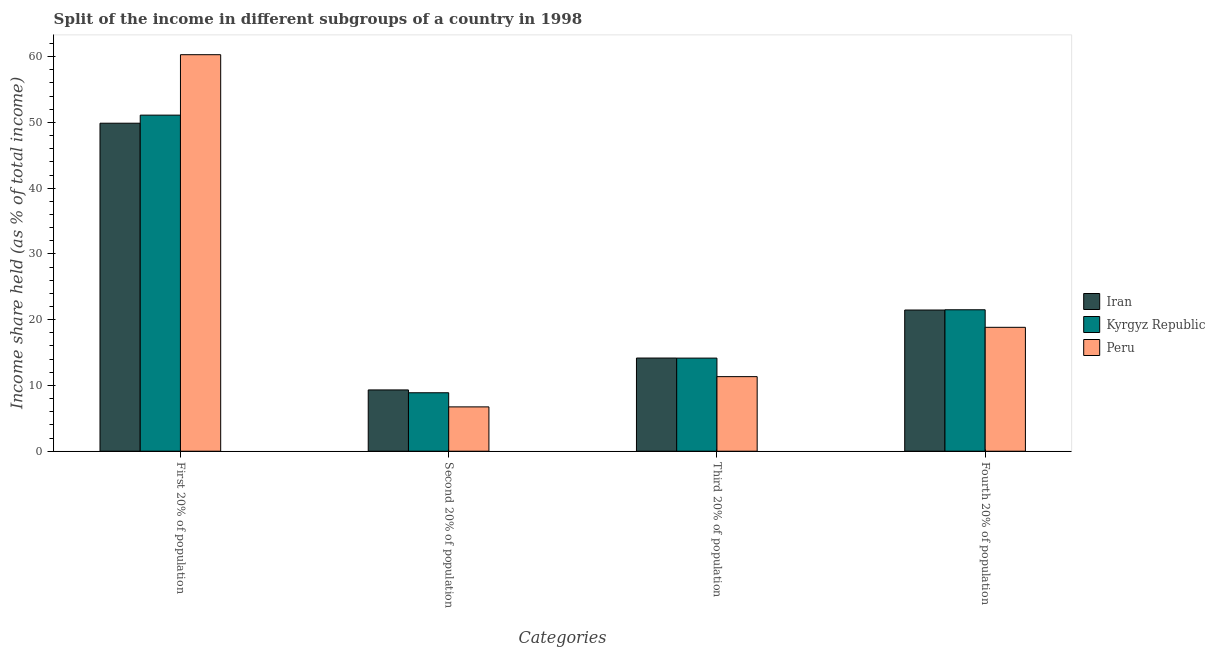How many different coloured bars are there?
Offer a terse response. 3. What is the label of the 1st group of bars from the left?
Make the answer very short. First 20% of population. What is the share of the income held by first 20% of the population in Kyrgyz Republic?
Your response must be concise. 51.11. Across all countries, what is the maximum share of the income held by fourth 20% of the population?
Keep it short and to the point. 21.51. Across all countries, what is the minimum share of the income held by second 20% of the population?
Make the answer very short. 6.74. In which country was the share of the income held by first 20% of the population maximum?
Give a very brief answer. Peru. What is the total share of the income held by third 20% of the population in the graph?
Provide a short and direct response. 39.67. What is the difference between the share of the income held by third 20% of the population in Iran and that in Kyrgyz Republic?
Your response must be concise. 0.01. What is the difference between the share of the income held by second 20% of the population in Kyrgyz Republic and the share of the income held by first 20% of the population in Iran?
Offer a terse response. -40.99. What is the average share of the income held by first 20% of the population per country?
Give a very brief answer. 53.76. What is the difference between the share of the income held by fourth 20% of the population and share of the income held by first 20% of the population in Kyrgyz Republic?
Make the answer very short. -29.6. What is the ratio of the share of the income held by fourth 20% of the population in Peru to that in Iran?
Provide a succinct answer. 0.88. Is the difference between the share of the income held by second 20% of the population in Kyrgyz Republic and Peru greater than the difference between the share of the income held by third 20% of the population in Kyrgyz Republic and Peru?
Your response must be concise. No. What is the difference between the highest and the second highest share of the income held by second 20% of the population?
Your answer should be very brief. 0.43. What is the difference between the highest and the lowest share of the income held by second 20% of the population?
Your response must be concise. 2.58. In how many countries, is the share of the income held by fourth 20% of the population greater than the average share of the income held by fourth 20% of the population taken over all countries?
Provide a succinct answer. 2. Is the sum of the share of the income held by second 20% of the population in Kyrgyz Republic and Peru greater than the maximum share of the income held by fourth 20% of the population across all countries?
Provide a succinct answer. No. Is it the case that in every country, the sum of the share of the income held by second 20% of the population and share of the income held by fourth 20% of the population is greater than the sum of share of the income held by third 20% of the population and share of the income held by first 20% of the population?
Your answer should be very brief. Yes. What does the 1st bar from the left in Second 20% of population represents?
Keep it short and to the point. Iran. How many bars are there?
Make the answer very short. 12. How many countries are there in the graph?
Ensure brevity in your answer.  3. What is the difference between two consecutive major ticks on the Y-axis?
Keep it short and to the point. 10. Are the values on the major ticks of Y-axis written in scientific E-notation?
Your answer should be very brief. No. Does the graph contain any zero values?
Keep it short and to the point. No. Does the graph contain grids?
Provide a short and direct response. No. What is the title of the graph?
Give a very brief answer. Split of the income in different subgroups of a country in 1998. Does "Slovak Republic" appear as one of the legend labels in the graph?
Make the answer very short. No. What is the label or title of the X-axis?
Offer a very short reply. Categories. What is the label or title of the Y-axis?
Make the answer very short. Income share held (as % of total income). What is the Income share held (as % of total income) in Iran in First 20% of population?
Provide a succinct answer. 49.88. What is the Income share held (as % of total income) of Kyrgyz Republic in First 20% of population?
Offer a very short reply. 51.11. What is the Income share held (as % of total income) in Peru in First 20% of population?
Provide a succinct answer. 60.3. What is the Income share held (as % of total income) of Iran in Second 20% of population?
Your response must be concise. 9.32. What is the Income share held (as % of total income) in Kyrgyz Republic in Second 20% of population?
Provide a short and direct response. 8.89. What is the Income share held (as % of total income) in Peru in Second 20% of population?
Make the answer very short. 6.74. What is the Income share held (as % of total income) in Iran in Third 20% of population?
Make the answer very short. 14.17. What is the Income share held (as % of total income) in Kyrgyz Republic in Third 20% of population?
Your answer should be compact. 14.16. What is the Income share held (as % of total income) in Peru in Third 20% of population?
Keep it short and to the point. 11.34. What is the Income share held (as % of total income) of Iran in Fourth 20% of population?
Keep it short and to the point. 21.47. What is the Income share held (as % of total income) in Kyrgyz Republic in Fourth 20% of population?
Offer a terse response. 21.51. What is the Income share held (as % of total income) of Peru in Fourth 20% of population?
Your answer should be compact. 18.84. Across all Categories, what is the maximum Income share held (as % of total income) of Iran?
Give a very brief answer. 49.88. Across all Categories, what is the maximum Income share held (as % of total income) in Kyrgyz Republic?
Your answer should be very brief. 51.11. Across all Categories, what is the maximum Income share held (as % of total income) in Peru?
Make the answer very short. 60.3. Across all Categories, what is the minimum Income share held (as % of total income) in Iran?
Offer a terse response. 9.32. Across all Categories, what is the minimum Income share held (as % of total income) in Kyrgyz Republic?
Your answer should be compact. 8.89. Across all Categories, what is the minimum Income share held (as % of total income) in Peru?
Your answer should be compact. 6.74. What is the total Income share held (as % of total income) of Iran in the graph?
Your answer should be very brief. 94.84. What is the total Income share held (as % of total income) in Kyrgyz Republic in the graph?
Your answer should be very brief. 95.67. What is the total Income share held (as % of total income) of Peru in the graph?
Your response must be concise. 97.22. What is the difference between the Income share held (as % of total income) in Iran in First 20% of population and that in Second 20% of population?
Keep it short and to the point. 40.56. What is the difference between the Income share held (as % of total income) in Kyrgyz Republic in First 20% of population and that in Second 20% of population?
Your answer should be very brief. 42.22. What is the difference between the Income share held (as % of total income) in Peru in First 20% of population and that in Second 20% of population?
Provide a succinct answer. 53.56. What is the difference between the Income share held (as % of total income) of Iran in First 20% of population and that in Third 20% of population?
Make the answer very short. 35.71. What is the difference between the Income share held (as % of total income) of Kyrgyz Republic in First 20% of population and that in Third 20% of population?
Offer a terse response. 36.95. What is the difference between the Income share held (as % of total income) in Peru in First 20% of population and that in Third 20% of population?
Keep it short and to the point. 48.96. What is the difference between the Income share held (as % of total income) of Iran in First 20% of population and that in Fourth 20% of population?
Offer a very short reply. 28.41. What is the difference between the Income share held (as % of total income) of Kyrgyz Republic in First 20% of population and that in Fourth 20% of population?
Ensure brevity in your answer.  29.6. What is the difference between the Income share held (as % of total income) in Peru in First 20% of population and that in Fourth 20% of population?
Offer a terse response. 41.46. What is the difference between the Income share held (as % of total income) in Iran in Second 20% of population and that in Third 20% of population?
Your answer should be very brief. -4.85. What is the difference between the Income share held (as % of total income) of Kyrgyz Republic in Second 20% of population and that in Third 20% of population?
Your answer should be compact. -5.27. What is the difference between the Income share held (as % of total income) in Peru in Second 20% of population and that in Third 20% of population?
Provide a succinct answer. -4.6. What is the difference between the Income share held (as % of total income) in Iran in Second 20% of population and that in Fourth 20% of population?
Your answer should be very brief. -12.15. What is the difference between the Income share held (as % of total income) of Kyrgyz Republic in Second 20% of population and that in Fourth 20% of population?
Your answer should be compact. -12.62. What is the difference between the Income share held (as % of total income) in Peru in Second 20% of population and that in Fourth 20% of population?
Offer a very short reply. -12.1. What is the difference between the Income share held (as % of total income) in Kyrgyz Republic in Third 20% of population and that in Fourth 20% of population?
Give a very brief answer. -7.35. What is the difference between the Income share held (as % of total income) in Iran in First 20% of population and the Income share held (as % of total income) in Kyrgyz Republic in Second 20% of population?
Your answer should be compact. 40.99. What is the difference between the Income share held (as % of total income) in Iran in First 20% of population and the Income share held (as % of total income) in Peru in Second 20% of population?
Provide a succinct answer. 43.14. What is the difference between the Income share held (as % of total income) in Kyrgyz Republic in First 20% of population and the Income share held (as % of total income) in Peru in Second 20% of population?
Provide a short and direct response. 44.37. What is the difference between the Income share held (as % of total income) in Iran in First 20% of population and the Income share held (as % of total income) in Kyrgyz Republic in Third 20% of population?
Offer a very short reply. 35.72. What is the difference between the Income share held (as % of total income) of Iran in First 20% of population and the Income share held (as % of total income) of Peru in Third 20% of population?
Your response must be concise. 38.54. What is the difference between the Income share held (as % of total income) of Kyrgyz Republic in First 20% of population and the Income share held (as % of total income) of Peru in Third 20% of population?
Provide a short and direct response. 39.77. What is the difference between the Income share held (as % of total income) of Iran in First 20% of population and the Income share held (as % of total income) of Kyrgyz Republic in Fourth 20% of population?
Make the answer very short. 28.37. What is the difference between the Income share held (as % of total income) of Iran in First 20% of population and the Income share held (as % of total income) of Peru in Fourth 20% of population?
Give a very brief answer. 31.04. What is the difference between the Income share held (as % of total income) in Kyrgyz Republic in First 20% of population and the Income share held (as % of total income) in Peru in Fourth 20% of population?
Ensure brevity in your answer.  32.27. What is the difference between the Income share held (as % of total income) of Iran in Second 20% of population and the Income share held (as % of total income) of Kyrgyz Republic in Third 20% of population?
Provide a short and direct response. -4.84. What is the difference between the Income share held (as % of total income) of Iran in Second 20% of population and the Income share held (as % of total income) of Peru in Third 20% of population?
Keep it short and to the point. -2.02. What is the difference between the Income share held (as % of total income) of Kyrgyz Republic in Second 20% of population and the Income share held (as % of total income) of Peru in Third 20% of population?
Provide a succinct answer. -2.45. What is the difference between the Income share held (as % of total income) in Iran in Second 20% of population and the Income share held (as % of total income) in Kyrgyz Republic in Fourth 20% of population?
Keep it short and to the point. -12.19. What is the difference between the Income share held (as % of total income) in Iran in Second 20% of population and the Income share held (as % of total income) in Peru in Fourth 20% of population?
Your answer should be compact. -9.52. What is the difference between the Income share held (as % of total income) in Kyrgyz Republic in Second 20% of population and the Income share held (as % of total income) in Peru in Fourth 20% of population?
Your answer should be compact. -9.95. What is the difference between the Income share held (as % of total income) of Iran in Third 20% of population and the Income share held (as % of total income) of Kyrgyz Republic in Fourth 20% of population?
Your response must be concise. -7.34. What is the difference between the Income share held (as % of total income) in Iran in Third 20% of population and the Income share held (as % of total income) in Peru in Fourth 20% of population?
Provide a short and direct response. -4.67. What is the difference between the Income share held (as % of total income) in Kyrgyz Republic in Third 20% of population and the Income share held (as % of total income) in Peru in Fourth 20% of population?
Offer a very short reply. -4.68. What is the average Income share held (as % of total income) in Iran per Categories?
Ensure brevity in your answer.  23.71. What is the average Income share held (as % of total income) in Kyrgyz Republic per Categories?
Ensure brevity in your answer.  23.92. What is the average Income share held (as % of total income) in Peru per Categories?
Provide a succinct answer. 24.3. What is the difference between the Income share held (as % of total income) of Iran and Income share held (as % of total income) of Kyrgyz Republic in First 20% of population?
Your response must be concise. -1.23. What is the difference between the Income share held (as % of total income) in Iran and Income share held (as % of total income) in Peru in First 20% of population?
Provide a succinct answer. -10.42. What is the difference between the Income share held (as % of total income) of Kyrgyz Republic and Income share held (as % of total income) of Peru in First 20% of population?
Give a very brief answer. -9.19. What is the difference between the Income share held (as % of total income) in Iran and Income share held (as % of total income) in Kyrgyz Republic in Second 20% of population?
Your answer should be compact. 0.43. What is the difference between the Income share held (as % of total income) of Iran and Income share held (as % of total income) of Peru in Second 20% of population?
Offer a terse response. 2.58. What is the difference between the Income share held (as % of total income) in Kyrgyz Republic and Income share held (as % of total income) in Peru in Second 20% of population?
Provide a succinct answer. 2.15. What is the difference between the Income share held (as % of total income) of Iran and Income share held (as % of total income) of Kyrgyz Republic in Third 20% of population?
Offer a very short reply. 0.01. What is the difference between the Income share held (as % of total income) in Iran and Income share held (as % of total income) in Peru in Third 20% of population?
Make the answer very short. 2.83. What is the difference between the Income share held (as % of total income) of Kyrgyz Republic and Income share held (as % of total income) of Peru in Third 20% of population?
Keep it short and to the point. 2.82. What is the difference between the Income share held (as % of total income) of Iran and Income share held (as % of total income) of Kyrgyz Republic in Fourth 20% of population?
Your answer should be very brief. -0.04. What is the difference between the Income share held (as % of total income) of Iran and Income share held (as % of total income) of Peru in Fourth 20% of population?
Provide a short and direct response. 2.63. What is the difference between the Income share held (as % of total income) in Kyrgyz Republic and Income share held (as % of total income) in Peru in Fourth 20% of population?
Your answer should be very brief. 2.67. What is the ratio of the Income share held (as % of total income) in Iran in First 20% of population to that in Second 20% of population?
Offer a very short reply. 5.35. What is the ratio of the Income share held (as % of total income) in Kyrgyz Republic in First 20% of population to that in Second 20% of population?
Provide a succinct answer. 5.75. What is the ratio of the Income share held (as % of total income) in Peru in First 20% of population to that in Second 20% of population?
Give a very brief answer. 8.95. What is the ratio of the Income share held (as % of total income) of Iran in First 20% of population to that in Third 20% of population?
Your response must be concise. 3.52. What is the ratio of the Income share held (as % of total income) in Kyrgyz Republic in First 20% of population to that in Third 20% of population?
Your answer should be very brief. 3.61. What is the ratio of the Income share held (as % of total income) in Peru in First 20% of population to that in Third 20% of population?
Provide a succinct answer. 5.32. What is the ratio of the Income share held (as % of total income) in Iran in First 20% of population to that in Fourth 20% of population?
Provide a short and direct response. 2.32. What is the ratio of the Income share held (as % of total income) in Kyrgyz Republic in First 20% of population to that in Fourth 20% of population?
Provide a succinct answer. 2.38. What is the ratio of the Income share held (as % of total income) of Peru in First 20% of population to that in Fourth 20% of population?
Offer a very short reply. 3.2. What is the ratio of the Income share held (as % of total income) in Iran in Second 20% of population to that in Third 20% of population?
Keep it short and to the point. 0.66. What is the ratio of the Income share held (as % of total income) in Kyrgyz Republic in Second 20% of population to that in Third 20% of population?
Your answer should be compact. 0.63. What is the ratio of the Income share held (as % of total income) in Peru in Second 20% of population to that in Third 20% of population?
Offer a very short reply. 0.59. What is the ratio of the Income share held (as % of total income) in Iran in Second 20% of population to that in Fourth 20% of population?
Provide a short and direct response. 0.43. What is the ratio of the Income share held (as % of total income) of Kyrgyz Republic in Second 20% of population to that in Fourth 20% of population?
Keep it short and to the point. 0.41. What is the ratio of the Income share held (as % of total income) of Peru in Second 20% of population to that in Fourth 20% of population?
Make the answer very short. 0.36. What is the ratio of the Income share held (as % of total income) of Iran in Third 20% of population to that in Fourth 20% of population?
Give a very brief answer. 0.66. What is the ratio of the Income share held (as % of total income) in Kyrgyz Republic in Third 20% of population to that in Fourth 20% of population?
Make the answer very short. 0.66. What is the ratio of the Income share held (as % of total income) of Peru in Third 20% of population to that in Fourth 20% of population?
Offer a very short reply. 0.6. What is the difference between the highest and the second highest Income share held (as % of total income) in Iran?
Make the answer very short. 28.41. What is the difference between the highest and the second highest Income share held (as % of total income) of Kyrgyz Republic?
Offer a terse response. 29.6. What is the difference between the highest and the second highest Income share held (as % of total income) in Peru?
Your answer should be very brief. 41.46. What is the difference between the highest and the lowest Income share held (as % of total income) in Iran?
Offer a very short reply. 40.56. What is the difference between the highest and the lowest Income share held (as % of total income) of Kyrgyz Republic?
Provide a succinct answer. 42.22. What is the difference between the highest and the lowest Income share held (as % of total income) of Peru?
Provide a succinct answer. 53.56. 